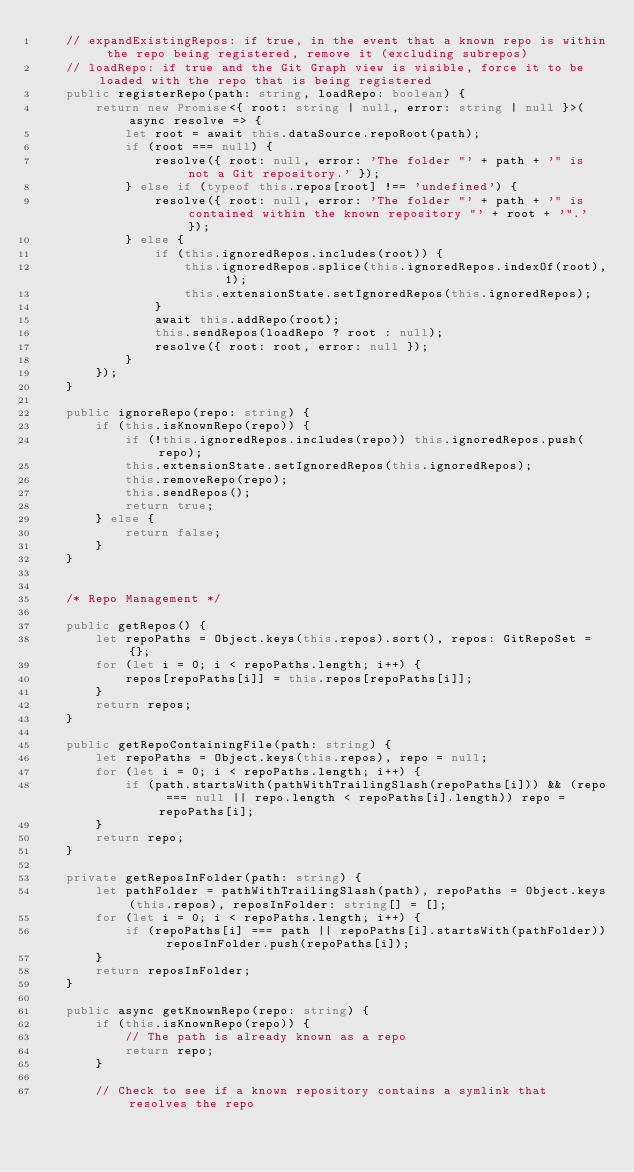Convert code to text. <code><loc_0><loc_0><loc_500><loc_500><_TypeScript_>	// expandExistingRepos: if true, in the event that a known repo is within the repo being registered, remove it (excluding subrepos)
	// loadRepo: if true and the Git Graph view is visible, force it to be loaded with the repo that is being registered
	public registerRepo(path: string, loadRepo: boolean) {
		return new Promise<{ root: string | null, error: string | null }>(async resolve => {
			let root = await this.dataSource.repoRoot(path);
			if (root === null) {
				resolve({ root: null, error: 'The folder "' + path + '" is not a Git repository.' });
			} else if (typeof this.repos[root] !== 'undefined') {
				resolve({ root: null, error: 'The folder "' + path + '" is contained within the known repository "' + root + '".' });
			} else {
				if (this.ignoredRepos.includes(root)) {
					this.ignoredRepos.splice(this.ignoredRepos.indexOf(root), 1);
					this.extensionState.setIgnoredRepos(this.ignoredRepos);
				}
				await this.addRepo(root);
				this.sendRepos(loadRepo ? root : null);
				resolve({ root: root, error: null });
			}
		});
	}

	public ignoreRepo(repo: string) {
		if (this.isKnownRepo(repo)) {
			if (!this.ignoredRepos.includes(repo)) this.ignoredRepos.push(repo);
			this.extensionState.setIgnoredRepos(this.ignoredRepos);
			this.removeRepo(repo);
			this.sendRepos();
			return true;
		} else {
			return false;
		}
	}


	/* Repo Management */

	public getRepos() {
		let repoPaths = Object.keys(this.repos).sort(), repos: GitRepoSet = {};
		for (let i = 0; i < repoPaths.length; i++) {
			repos[repoPaths[i]] = this.repos[repoPaths[i]];
		}
		return repos;
	}

	public getRepoContainingFile(path: string) {
		let repoPaths = Object.keys(this.repos), repo = null;
		for (let i = 0; i < repoPaths.length; i++) {
			if (path.startsWith(pathWithTrailingSlash(repoPaths[i])) && (repo === null || repo.length < repoPaths[i].length)) repo = repoPaths[i];
		}
		return repo;
	}

	private getReposInFolder(path: string) {
		let pathFolder = pathWithTrailingSlash(path), repoPaths = Object.keys(this.repos), reposInFolder: string[] = [];
		for (let i = 0; i < repoPaths.length; i++) {
			if (repoPaths[i] === path || repoPaths[i].startsWith(pathFolder)) reposInFolder.push(repoPaths[i]);
		}
		return reposInFolder;
	}

	public async getKnownRepo(repo: string) {
		if (this.isKnownRepo(repo)) {
			// The path is already known as a repo
			return repo;
		}

		// Check to see if a known repository contains a symlink that resolves the repo</code> 